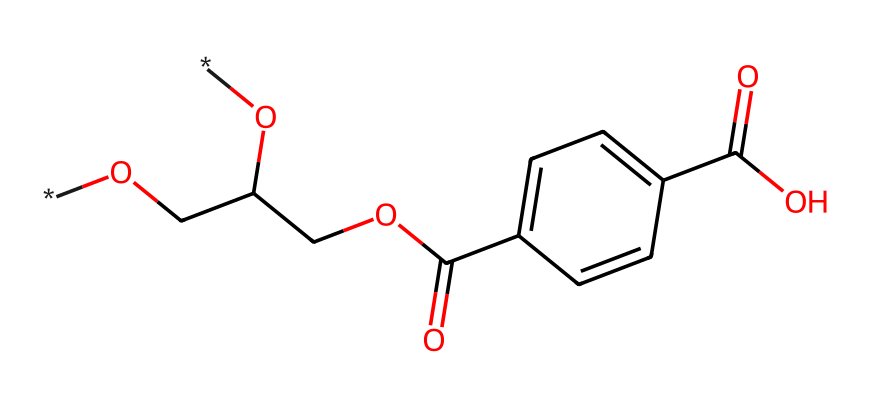How many carbon atoms are in the molecular structure? By analyzing the SMILES representation, we can count the carbon atoms present in the chain and rings. 'C' and 'c' in the SMILES notation indicate carbon atoms. In total, there are 10 carbon atoms.
Answer: 10 What type of functional groups are present in this chemical? The SMILES indicates the presence of carboxylic acid (–COOH), ester (–COO–), and alcohol (–OH) functional groups, as inferred from 'C(=O)O', 'COC(=O)', and 'O' in the structure.
Answer: carboxylic acid, ester, alcohol What is the molecular formula of this compound? By interpreting the SMILES and counting the atoms: C: 10, H: 10, O: 4; we can compile these counts to get the molecular formula C10H10O4.
Answer: C10H10O4 Why is polyethylene terephthalate (PET) favored for motorcycle helmet visors? The structural composition includes features that provide clarity, toughness, and UV resistance, making PET ideal for protective gear.
Answer: clarity, toughness, UV resistance How does the presence of the carboxylic acid affect the properties of PET? Carboxylic acid groups contribute to hydrogen bonding, which enhances thermal stability and adhesion properties in the polymer, thereby improving its performance in helmet visors.
Answer: enhances thermal stability What characteristic of PET contributes to its impact resistance in helmet visors? The polymer's long-chain structure and inter-chain interactions give it excellent impact resistance properties, crucial for safety in motorcycle helmets.
Answer: long-chain structure and inter-chain interactions What is the significance of the ester bond in the structure? The ester bond contributes to the flexibility and strength of the polymer chains, which are essential for durability in everyday use as helmet visors.
Answer: flexibility and strength 